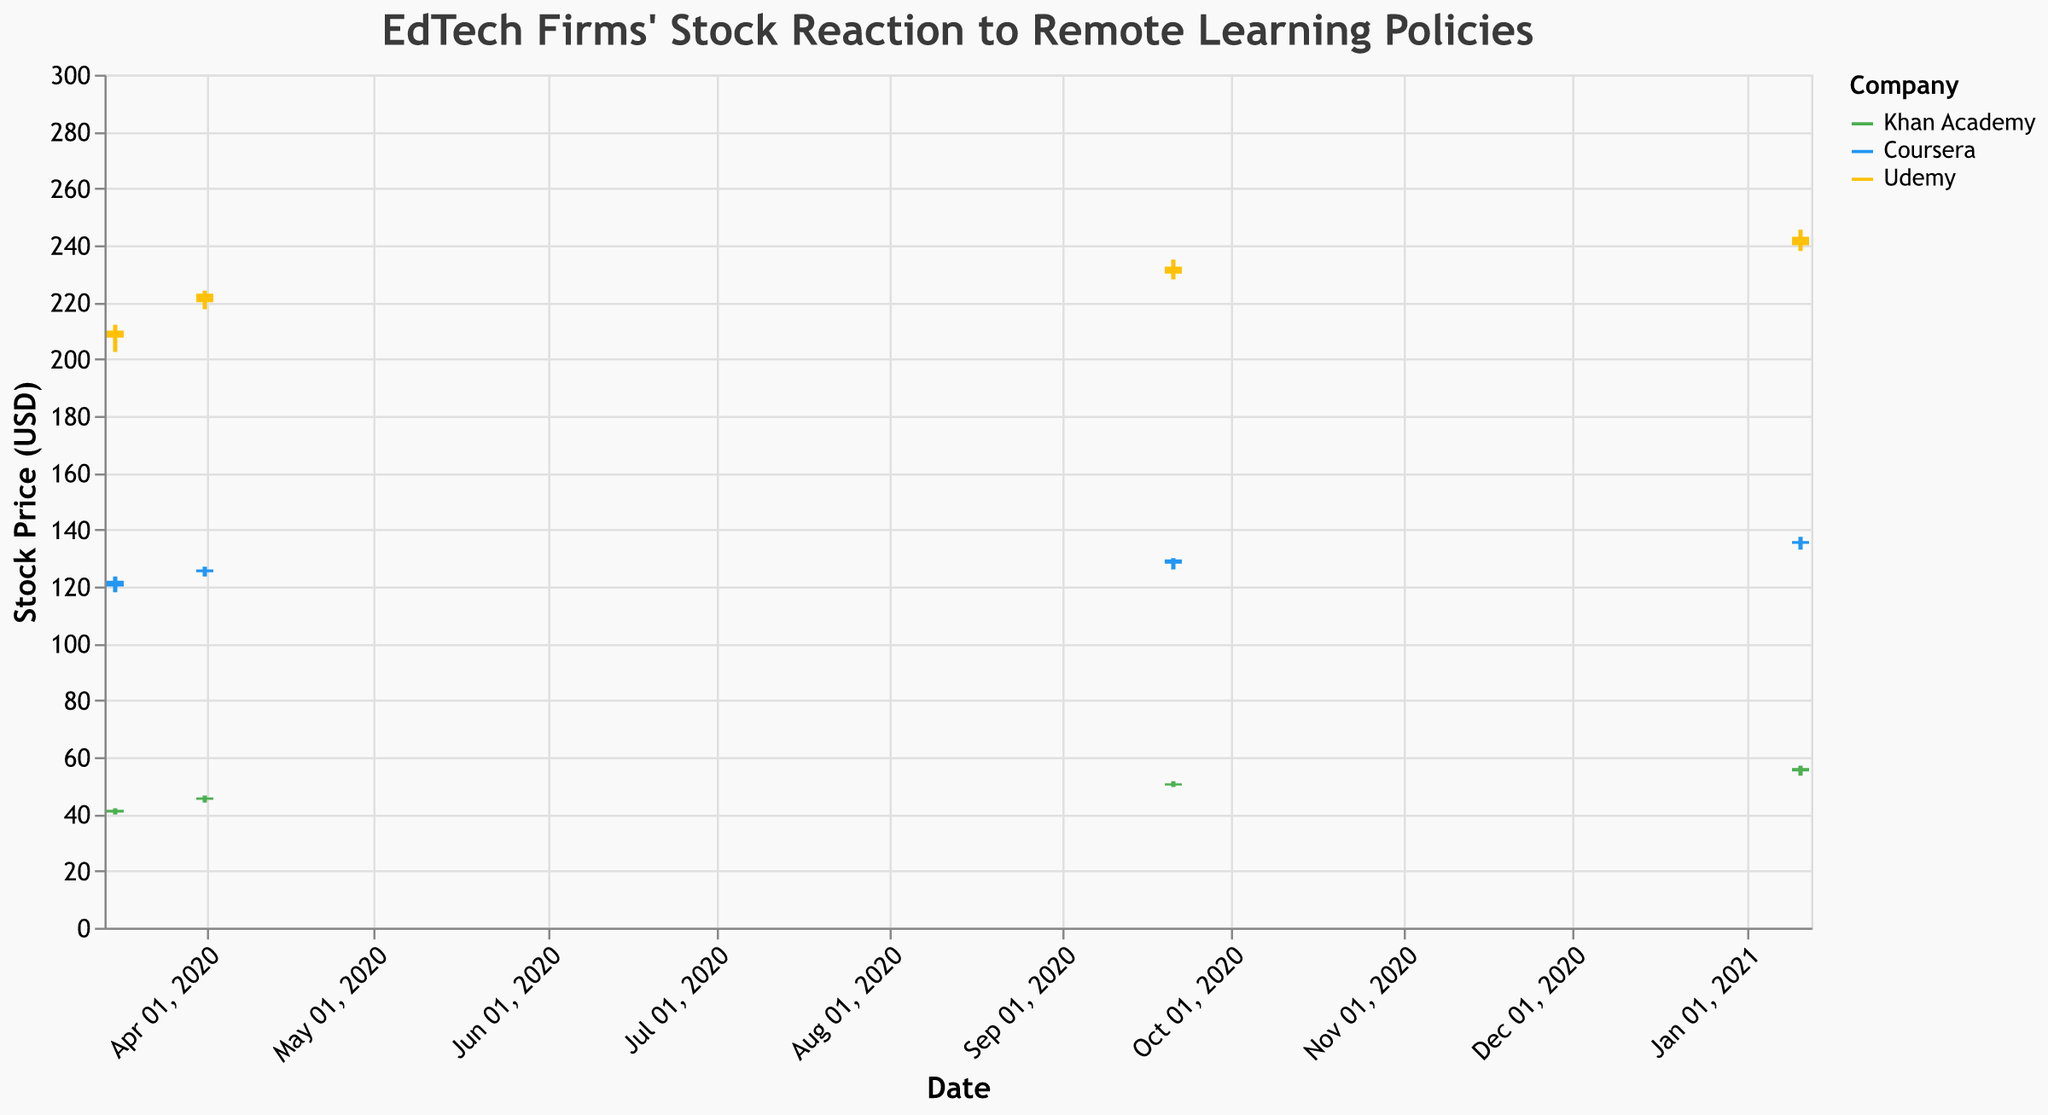What is the title of the plot? The title of the plot is mentioned at the very top and provides a summary of the graphical data presented. It reads "EdTech Firms' Stock Reaction to Remote Learning Policies."
Answer: EdTech Firms' Stock Reaction to Remote Learning Policies How many companies are represented in the plot? The legend indicates three different companies, each represented by distinct colors. These companies are Khan Academy, Coursera, and Udemy.
Answer: Three On which date did the Khan Academy have the highest closing price? By examining the y-axis values corresponding to the closing prices of Khan Academy's stock at different dates, we can see that the highest closing price was on January 11, 2021.
Answer: January 11, 2021 Compare the stock performance of Coursera and Udemy on March 16, 2020. Which one closed higher? On March 16, 2020, Coursera's stock closed at 122.0, whereas Udemy's stock closed at 207.5. By comparing these values, we conclude that Udemy closed higher.
Answer: Udemy What was the stock price range for Khan Academy on January 11, 2021? The stock price range can be determined by the difference between the high and low prices for that day. For Khan Academy, the high was 57.0 and the low was 53.5, giving a range of 57.0 - 53.5 = 3.5.
Answer: 3.5 Which company had the highest trading volume on January 11, 2021? By reviewing the volume data on that date, we see that Coursera had the highest trading volume at 2,300,000.
Answer: Coursera What was the closing price of Udemy on April 1, 2020? Look at the closing price for Udemy on April 1, 2020, which is shown as 223.0.
Answer: 223.0 How did the closing price of Coursera change from March 16, 2020, to April 1, 2020? On March 16, 2020, Coursera's closing price was 122.0, and on April 1, 2020, it was 126.0. The change is calculated as 126.0 - 122.0 = 4.0.
Answer: 4.0 Which policy announcement was associated with the highest closing price for Udemy? Observe the closing prices for each policy announcement. For Udemy, the highest closing price of 243.0 was on January 11, 2021, during the Federal Digital Divide Initiative.
Answer: Federal Digital Divide Initiative 